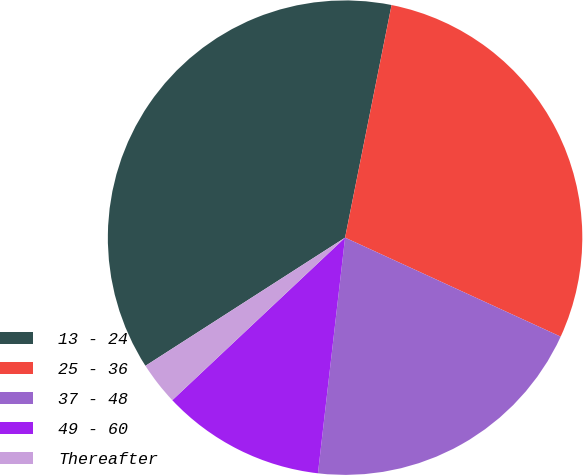Convert chart. <chart><loc_0><loc_0><loc_500><loc_500><pie_chart><fcel>13 - 24<fcel>25 - 36<fcel>37 - 48<fcel>49 - 60<fcel>Thereafter<nl><fcel>37.22%<fcel>28.71%<fcel>19.97%<fcel>11.16%<fcel>2.93%<nl></chart> 